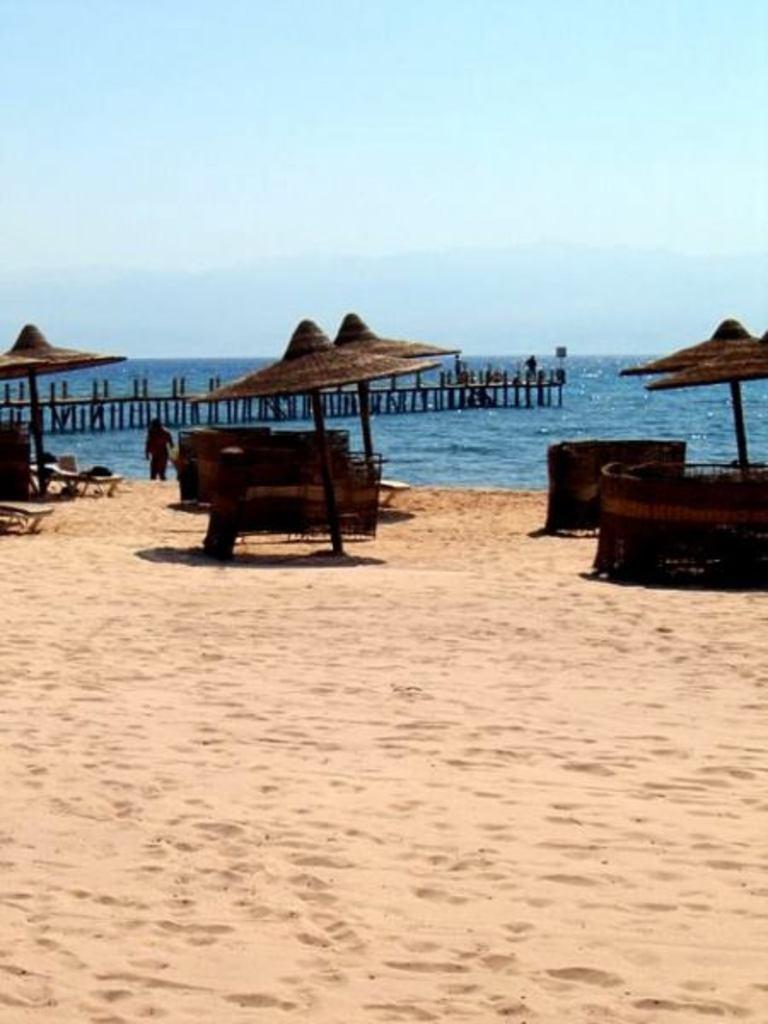Could you give a brief overview of what you see in this image? In this picture we can see umbrellas, chairs, some objects and a person standing on sand and in the background we can see two people standing on a path, water, sky. 